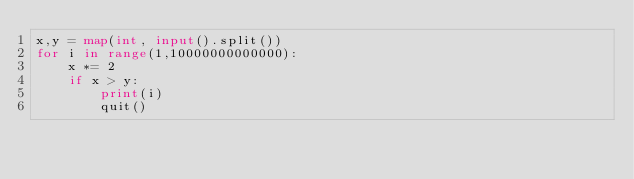<code> <loc_0><loc_0><loc_500><loc_500><_Python_>x,y = map(int, input().split())
for i in range(1,10000000000000):
    x *= 2
    if x > y:
        print(i)
        quit()</code> 